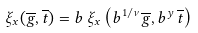Convert formula to latex. <formula><loc_0><loc_0><loc_500><loc_500>\xi _ { x } ( \overline { g } , \overline { t } ) = b \, \xi _ { x } \left ( b ^ { 1 / \nu } \overline { g } , b ^ { y } \, \overline { t } \right )</formula> 